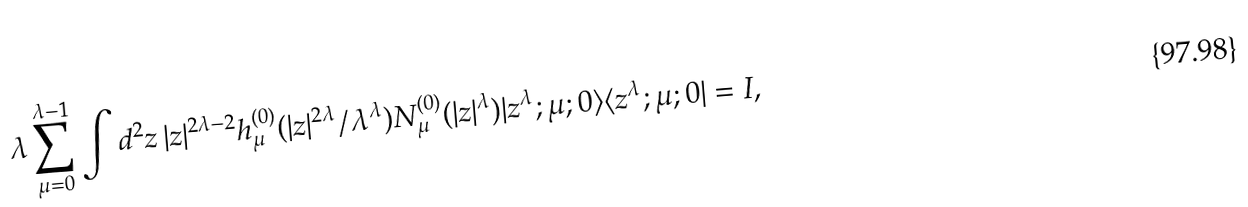Convert formula to latex. <formula><loc_0><loc_0><loc_500><loc_500>\lambda \sum _ { \mu = 0 } ^ { \lambda - 1 } \int d ^ { 2 } z \, | z | ^ { 2 \lambda - 2 } h ^ { ( 0 ) } _ { \mu } ( | z | ^ { 2 \lambda } / \lambda ^ { \lambda } ) N ^ { ( 0 ) } _ { \mu } ( | z | ^ { \lambda } ) | z ^ { \lambda } ; \mu ; 0 \rangle \langle z ^ { \lambda } ; \mu ; 0 | = I ,</formula> 